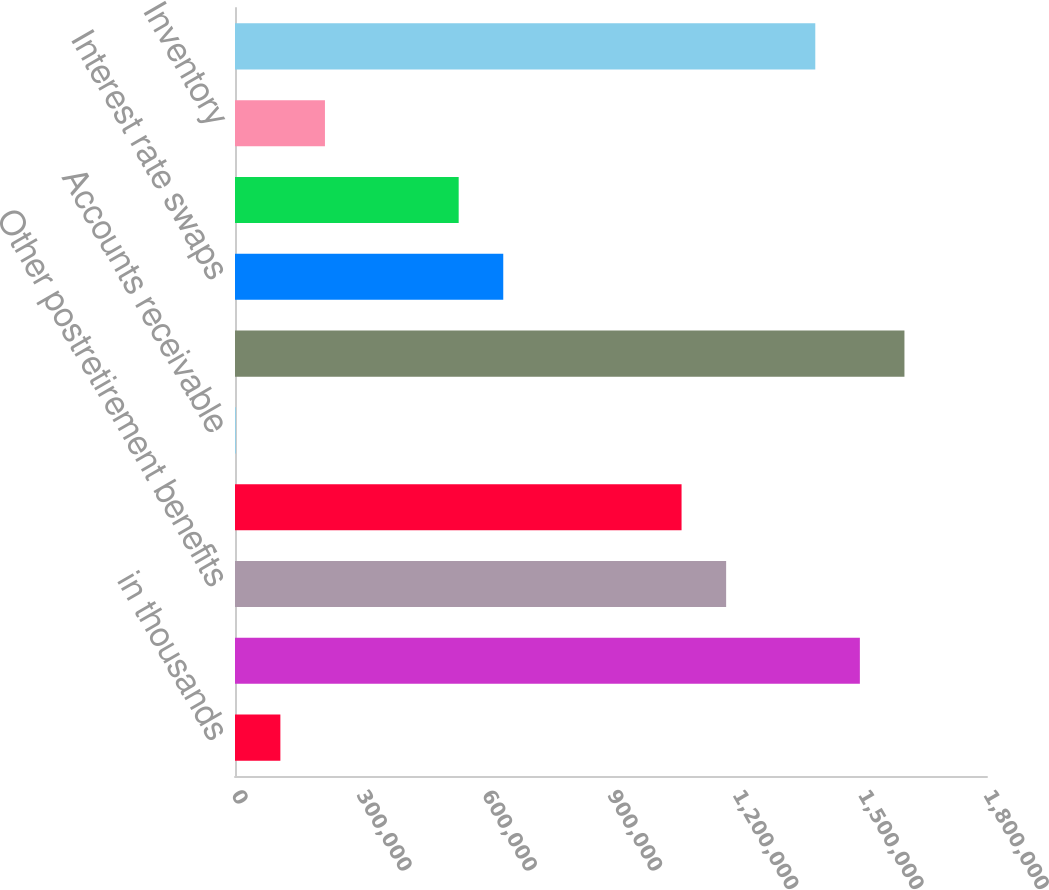<chart> <loc_0><loc_0><loc_500><loc_500><bar_chart><fcel>in thousands<fcel>Pensions<fcel>Other postretirement benefits<fcel>Asset retirement obligations<fcel>Accounts receivable<fcel>Deferred compensation vacation<fcel>Interest rate swaps<fcel>Self-insurance reserves<fcel>Inventory<fcel>Federal net operating loss<nl><fcel>108609<fcel>1.49569e+06<fcel>1.17559e+06<fcel>1.0689e+06<fcel>1910<fcel>1.60239e+06<fcel>642102<fcel>535403<fcel>215307<fcel>1.38899e+06<nl></chart> 